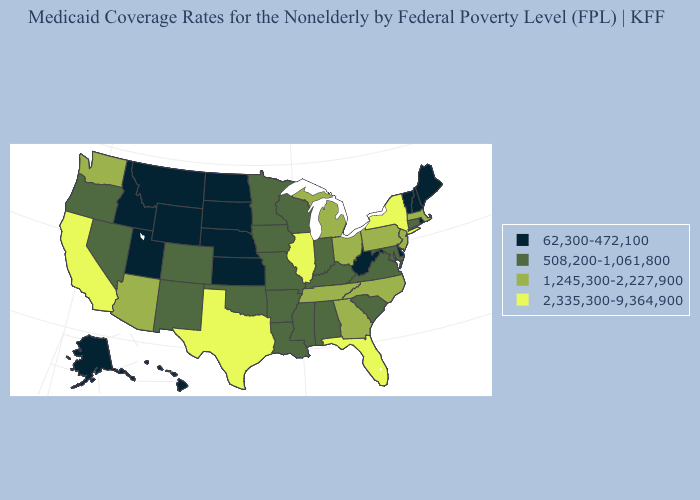Name the states that have a value in the range 508,200-1,061,800?
Write a very short answer. Alabama, Arkansas, Colorado, Connecticut, Indiana, Iowa, Kentucky, Louisiana, Maryland, Minnesota, Mississippi, Missouri, Nevada, New Mexico, Oklahoma, Oregon, South Carolina, Virginia, Wisconsin. What is the highest value in the South ?
Keep it brief. 2,335,300-9,364,900. What is the value of Louisiana?
Give a very brief answer. 508,200-1,061,800. Which states have the lowest value in the Northeast?
Give a very brief answer. Maine, New Hampshire, Rhode Island, Vermont. Name the states that have a value in the range 62,300-472,100?
Concise answer only. Alaska, Delaware, Hawaii, Idaho, Kansas, Maine, Montana, Nebraska, New Hampshire, North Dakota, Rhode Island, South Dakota, Utah, Vermont, West Virginia, Wyoming. Name the states that have a value in the range 508,200-1,061,800?
Concise answer only. Alabama, Arkansas, Colorado, Connecticut, Indiana, Iowa, Kentucky, Louisiana, Maryland, Minnesota, Mississippi, Missouri, Nevada, New Mexico, Oklahoma, Oregon, South Carolina, Virginia, Wisconsin. What is the highest value in the Northeast ?
Answer briefly. 2,335,300-9,364,900. What is the highest value in states that border New Mexico?
Answer briefly. 2,335,300-9,364,900. Does Georgia have the highest value in the USA?
Give a very brief answer. No. Name the states that have a value in the range 508,200-1,061,800?
Concise answer only. Alabama, Arkansas, Colorado, Connecticut, Indiana, Iowa, Kentucky, Louisiana, Maryland, Minnesota, Mississippi, Missouri, Nevada, New Mexico, Oklahoma, Oregon, South Carolina, Virginia, Wisconsin. What is the value of California?
Write a very short answer. 2,335,300-9,364,900. What is the value of West Virginia?
Write a very short answer. 62,300-472,100. Which states hav the highest value in the West?
Give a very brief answer. California. Among the states that border Kansas , does Missouri have the lowest value?
Concise answer only. No. Does Alabama have the lowest value in the South?
Give a very brief answer. No. 